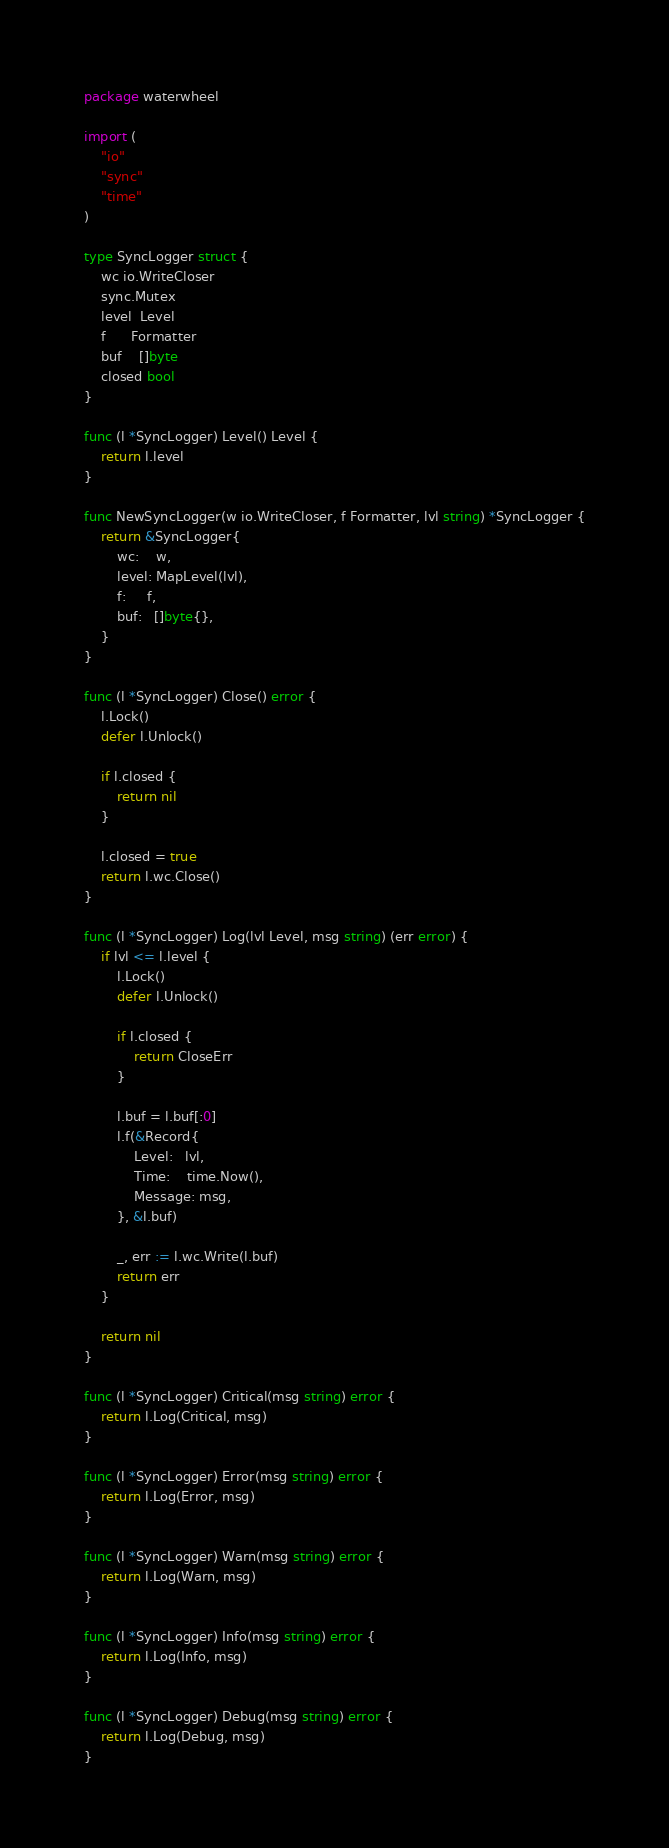<code> <loc_0><loc_0><loc_500><loc_500><_Go_>package waterwheel

import (
	"io"
	"sync"
	"time"
)

type SyncLogger struct {
	wc io.WriteCloser
	sync.Mutex
	level  Level
	f      Formatter
	buf    []byte
	closed bool
}

func (l *SyncLogger) Level() Level {
	return l.level
}

func NewSyncLogger(w io.WriteCloser, f Formatter, lvl string) *SyncLogger {
	return &SyncLogger{
		wc:    w,
		level: MapLevel(lvl),
		f:     f,
		buf:   []byte{},
	}
}

func (l *SyncLogger) Close() error {
	l.Lock()
	defer l.Unlock()

	if l.closed {
		return nil
	}

	l.closed = true
	return l.wc.Close()
}

func (l *SyncLogger) Log(lvl Level, msg string) (err error) {
	if lvl <= l.level {
		l.Lock()
		defer l.Unlock()

		if l.closed {
			return CloseErr
		}

		l.buf = l.buf[:0]
		l.f(&Record{
			Level:   lvl,
			Time:    time.Now(),
			Message: msg,
		}, &l.buf)

		_, err := l.wc.Write(l.buf)
		return err
	}

	return nil
}

func (l *SyncLogger) Critical(msg string) error {
	return l.Log(Critical, msg)
}

func (l *SyncLogger) Error(msg string) error {
	return l.Log(Error, msg)
}

func (l *SyncLogger) Warn(msg string) error {
	return l.Log(Warn, msg)
}

func (l *SyncLogger) Info(msg string) error {
	return l.Log(Info, msg)
}

func (l *SyncLogger) Debug(msg string) error {
	return l.Log(Debug, msg)
}
</code> 